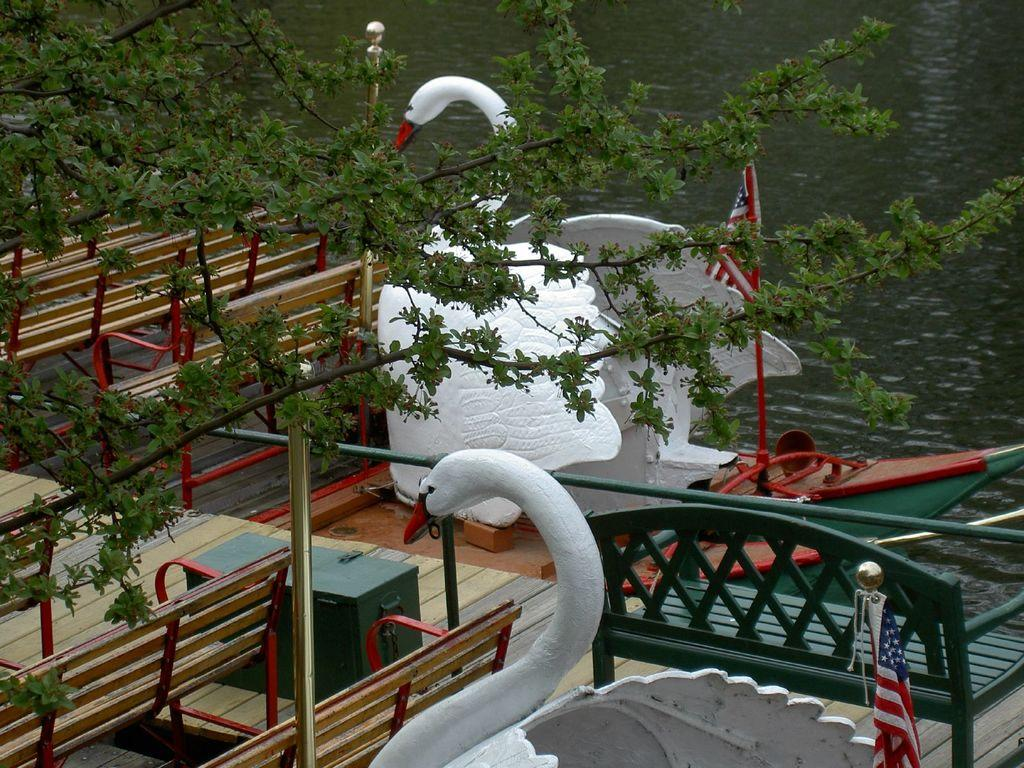What type of seating is present in the image? There are benches in the image. What decorative structures can be seen in the image? There are swan structures in the image. What is attached to the poles in the image? There are flags attached to the poles in the image. What are the poles used for in the image? The poles are used to hold the flags in the image. What type of vegetation is on the left side of the image? There is a tree on the left side of the image. What is visible at the top of the image? There is water visible at the top of the image. What type of treatment is being administered to the swan structures in the image? There is no treatment being administered to the swan structures in the image; they are decorative elements. Has the water at the top of the image received any approval for its quality? There is no indication of water quality or approval in the image. 